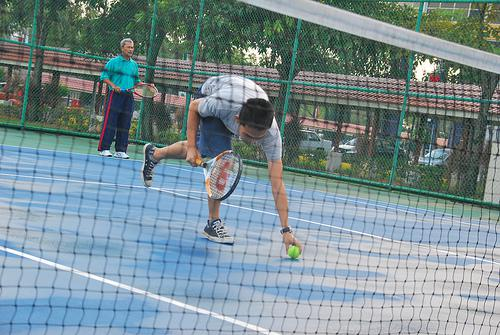Question: when this picture was taken?
Choices:
A. During the day.
B. Morning.
C. Noon.
D. Evening.
Answer with the letter. Answer: A Question: what they are doing?
Choices:
A. Playing badmitten.
B. Playing racquetball.
C. Playing tennis.
D. Playing basketball.
Answer with the letter. Answer: C Question: why they have rackets?
Choices:
A. Because they're modeling for a photo shoot.
B. Because they are playing tennis.
C. Because they're getting ready for Wimbledon.
D. Because they just bought them from the store.
Answer with the letter. Answer: B Question: what is the tennis court's color?
Choices:
A. It is red.
B. It is white.
C. It is black.
D. Is blue and green.
Answer with the letter. Answer: D Question: what is the color of the t-shirt of the first man?
Choices:
A. Is white.
B. It is black.
C. It is purple.
D. It is silver.
Answer with the letter. Answer: A Question: where this picture was taken?
Choices:
A. In a tennis court.
B. Basketball court.
C. Gym.
D. Soccer field.
Answer with the letter. Answer: A 